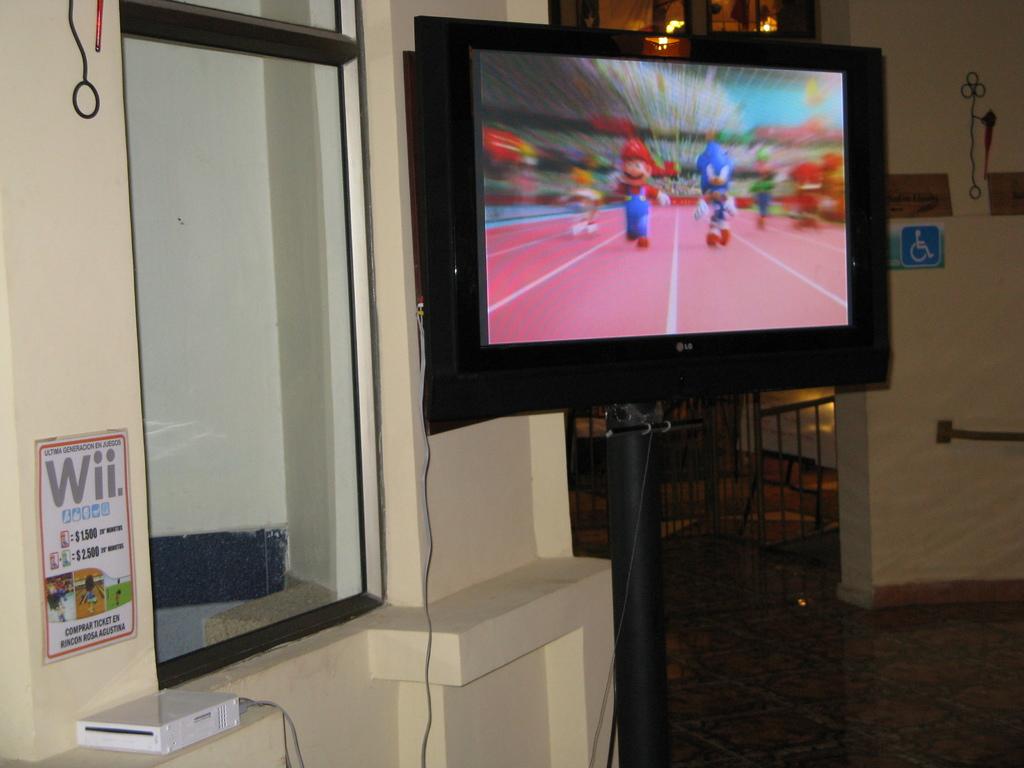What gaming system is this?
Your response must be concise. Wii. What brand is the tv?
Offer a very short reply. Lg. 